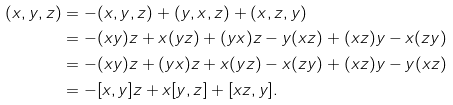<formula> <loc_0><loc_0><loc_500><loc_500>( x , y , z ) & = - ( x , y , z ) + ( y , x , z ) + ( x , z , y ) & \\ & = - ( x y ) z + x ( y z ) + ( y x ) z - y ( x z ) + ( x z ) y - x ( z y ) & \\ & = - ( x y ) z + ( y x ) z + x ( y z ) - x ( z y ) + ( x z ) y - y ( x z ) & \\ & = - [ x , y ] z + x [ y , z ] + [ x z , y ] .</formula> 